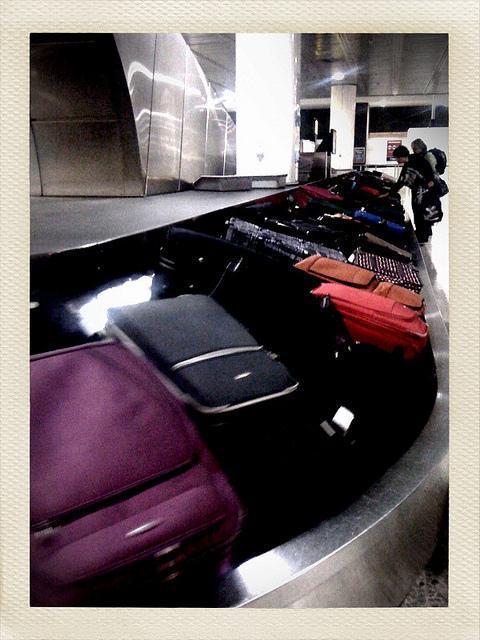How many blue suitcases are there?
Give a very brief answer. 1. How many people are visible?
Give a very brief answer. 2. How many suitcases are in the photo?
Give a very brief answer. 6. 